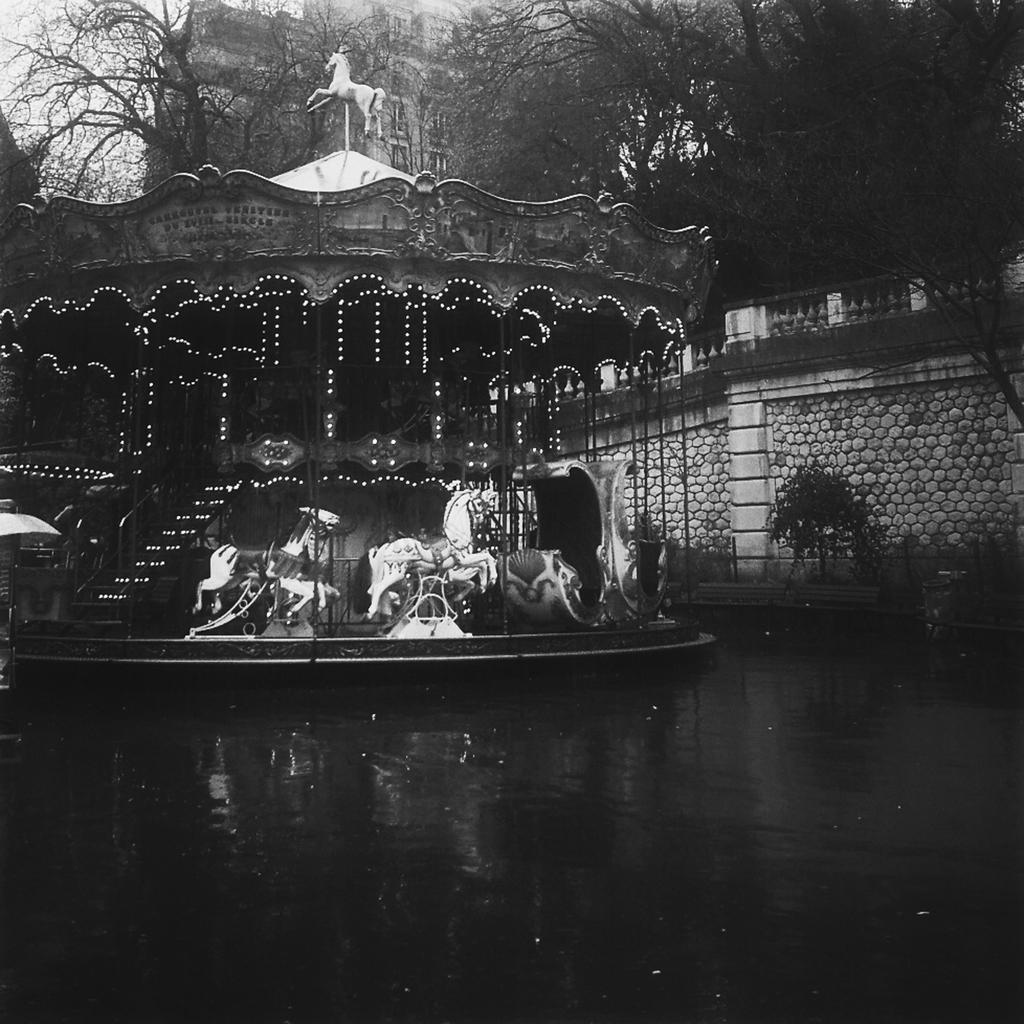Could you give a brief overview of what you see in this image? This is a black and white picture. At the bottom, we see water and this water might be in the canal. In the middle, we see a carousel. On the right side, we see the trees, railing and a wall. There are trees and buildings in the background. 